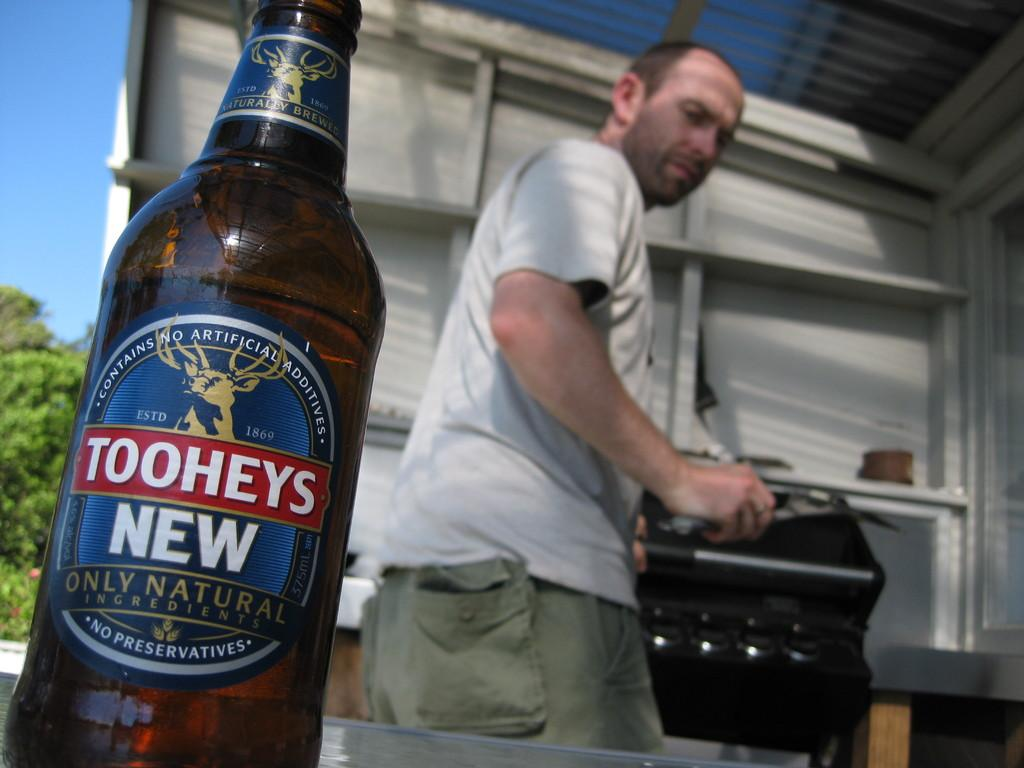<image>
Relay a brief, clear account of the picture shown. a man grilling outside with a bottle of Toohey's in the foreground 